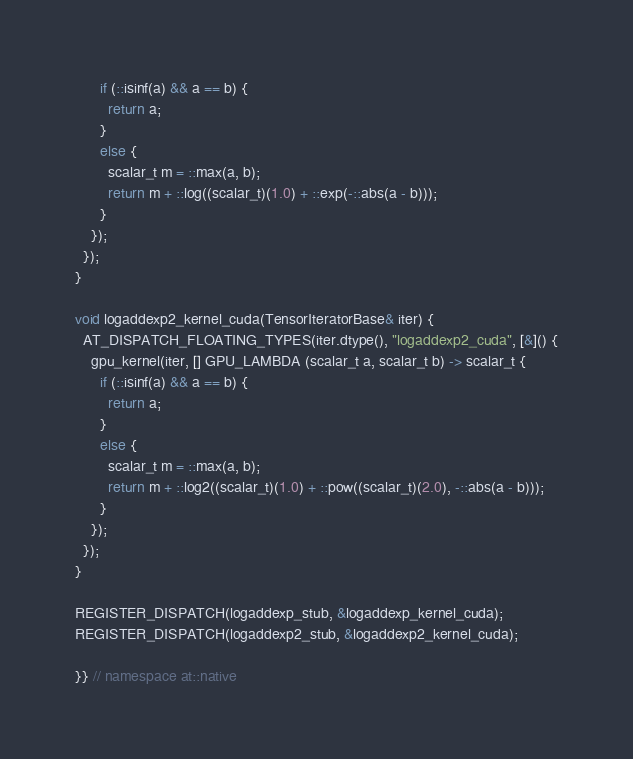<code> <loc_0><loc_0><loc_500><loc_500><_Cuda_>      if (::isinf(a) && a == b) {
        return a;
      }
      else {
        scalar_t m = ::max(a, b);
        return m + ::log((scalar_t)(1.0) + ::exp(-::abs(a - b)));
      }
    });
  });
}

void logaddexp2_kernel_cuda(TensorIteratorBase& iter) {
  AT_DISPATCH_FLOATING_TYPES(iter.dtype(), "logaddexp2_cuda", [&]() {
    gpu_kernel(iter, [] GPU_LAMBDA (scalar_t a, scalar_t b) -> scalar_t {
      if (::isinf(a) && a == b) {
        return a;
      }
      else {
        scalar_t m = ::max(a, b);
        return m + ::log2((scalar_t)(1.0) + ::pow((scalar_t)(2.0), -::abs(a - b)));
      }
    });
  });
}

REGISTER_DISPATCH(logaddexp_stub, &logaddexp_kernel_cuda);
REGISTER_DISPATCH(logaddexp2_stub, &logaddexp2_kernel_cuda);

}} // namespace at::native
</code> 